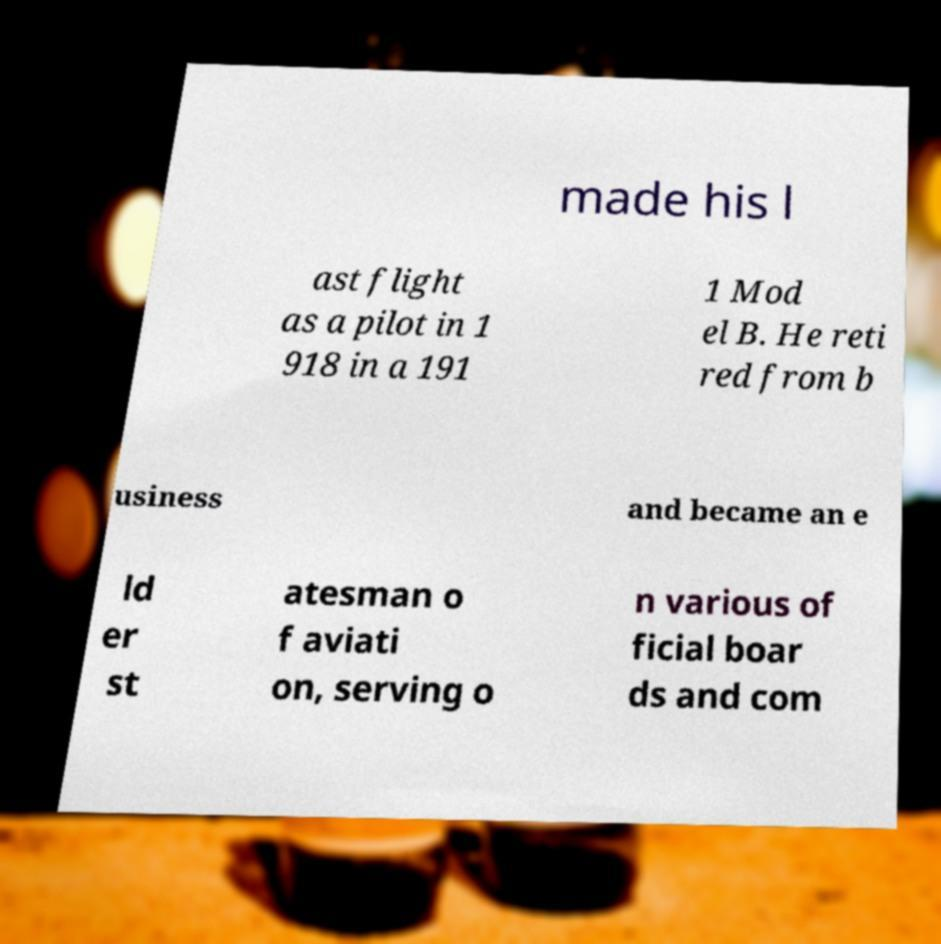Can you accurately transcribe the text from the provided image for me? made his l ast flight as a pilot in 1 918 in a 191 1 Mod el B. He reti red from b usiness and became an e ld er st atesman o f aviati on, serving o n various of ficial boar ds and com 